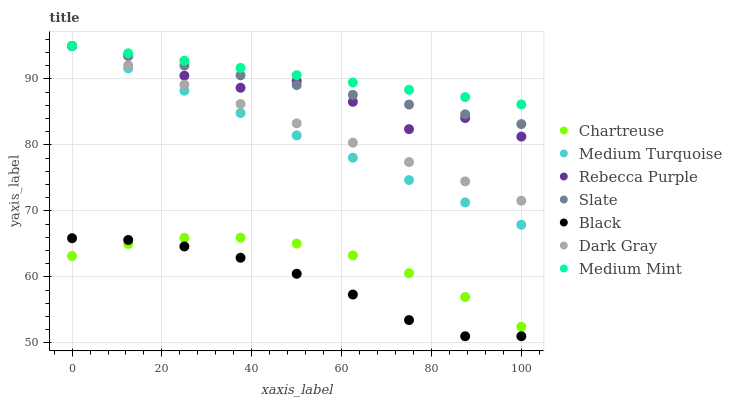Does Black have the minimum area under the curve?
Answer yes or no. Yes. Does Medium Mint have the maximum area under the curve?
Answer yes or no. Yes. Does Slate have the minimum area under the curve?
Answer yes or no. No. Does Slate have the maximum area under the curve?
Answer yes or no. No. Is Dark Gray the smoothest?
Answer yes or no. Yes. Is Rebecca Purple the roughest?
Answer yes or no. Yes. Is Slate the smoothest?
Answer yes or no. No. Is Slate the roughest?
Answer yes or no. No. Does Black have the lowest value?
Answer yes or no. Yes. Does Slate have the lowest value?
Answer yes or no. No. Does Medium Turquoise have the highest value?
Answer yes or no. Yes. Does Chartreuse have the highest value?
Answer yes or no. No. Is Chartreuse less than Medium Turquoise?
Answer yes or no. Yes. Is Rebecca Purple greater than Chartreuse?
Answer yes or no. Yes. Does Medium Mint intersect Rebecca Purple?
Answer yes or no. Yes. Is Medium Mint less than Rebecca Purple?
Answer yes or no. No. Is Medium Mint greater than Rebecca Purple?
Answer yes or no. No. Does Chartreuse intersect Medium Turquoise?
Answer yes or no. No. 